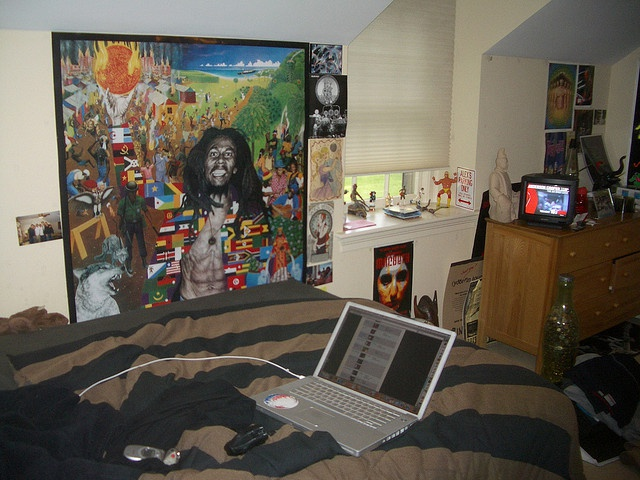Describe the objects in this image and their specific colors. I can see bed in darkgray, black, and gray tones, laptop in darkgray, gray, and black tones, tv in darkgray, black, gray, and lavender tones, bottle in darkgray, black, darkgreen, and gray tones, and remote in darkgray, gray, and black tones in this image. 